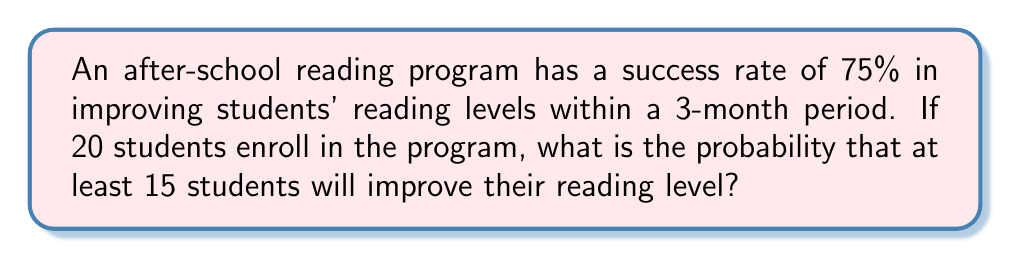Could you help me with this problem? To solve this problem, we'll use the binomial probability distribution.

1. Let X be the number of students who improve their reading level.
2. We want P(X ≥ 15).
3. n = 20 (total number of students)
4. p = 0.75 (probability of success for each student)
5. We need to calculate: P(X ≥ 15) = P(X = 15) + P(X = 16) + P(X = 17) + P(X = 18) + P(X = 19) + P(X = 20)

Using the binomial probability formula:

$$P(X = k) = \binom{n}{k} p^k (1-p)^{n-k}$$

For each value of k from 15 to 20:

$$P(X = 15) = \binom{20}{15} (0.75)^{15} (0.25)^5 = 0.2002$$
$$P(X = 16) = \binom{20}{16} (0.75)^{16} (0.25)^4 = 0.2670$$
$$P(X = 17) = \binom{20}{17} (0.75)^{17} (0.25)^3 = 0.2448$$
$$P(X = 18) = \binom{20}{18} (0.75)^{18} (0.25)^2 = 0.1544$$
$$P(X = 19) = \binom{20}{19} (0.75)^{19} (0.25)^1 = 0.0631$$
$$P(X = 20) = \binom{20}{20} (0.75)^{20} (0.25)^0 = 0.0032$$

Sum these probabilities:

$$P(X ≥ 15) = 0.2002 + 0.2670 + 0.2448 + 0.1544 + 0.0631 + 0.0032 = 0.9327$$
Answer: 0.9327 or 93.27% 